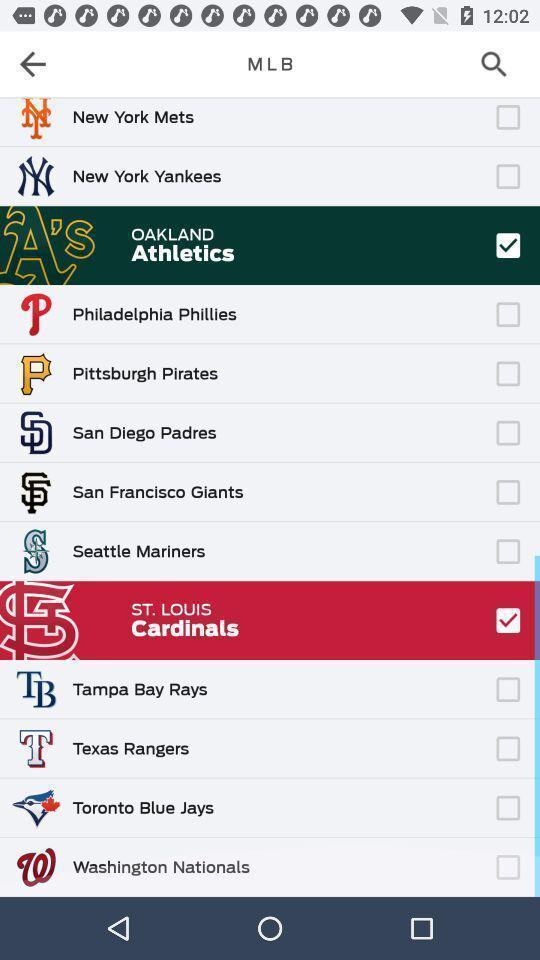What can you discern from this picture? Page displaying selected options in sports application. 